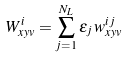Convert formula to latex. <formula><loc_0><loc_0><loc_500><loc_500>W _ { x y v } ^ { i } = \sum _ { j = 1 } ^ { N _ { L } } \epsilon _ { j } \, w _ { x y v } ^ { i j }</formula> 